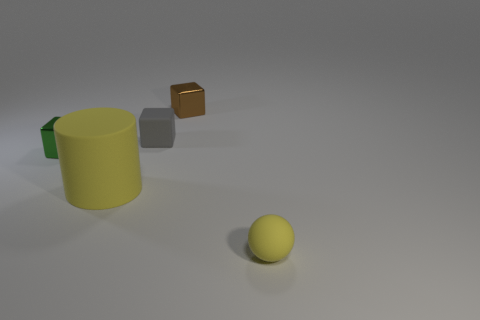Is there any movement suggested in this image? While the image itself is static, there is an implication of movement. The brown cube appears to be suspended in the air with a shadow beneath it, suggesting it might be in the process of falling or floating. Additionally, the positioning of the objects could imply a sequence of events, like the cube being knocked over and the smaller objects moving as a result. 